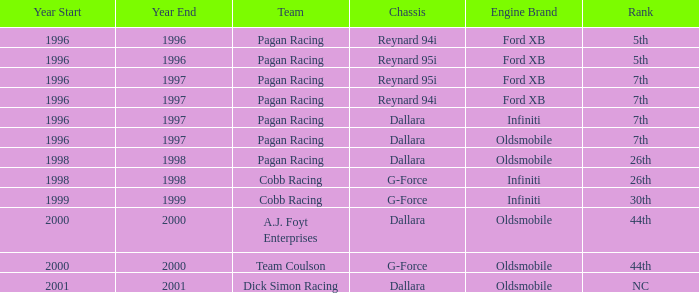Which engine finished 7th with the reynard 95i chassis? Ford XB. 